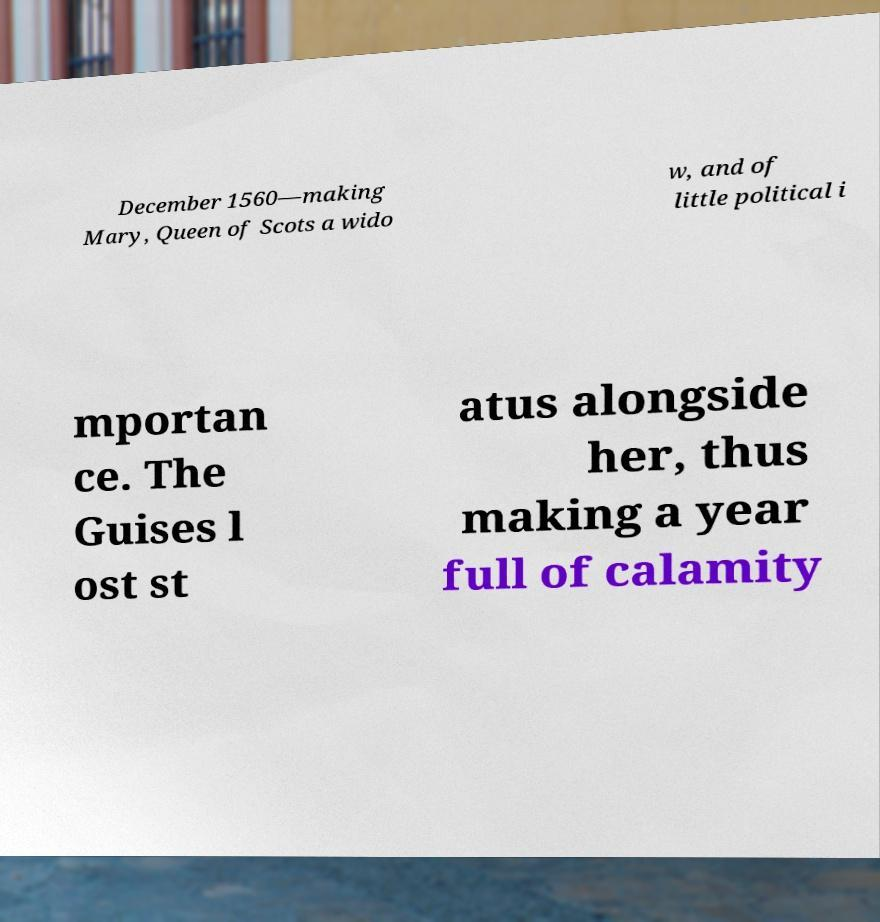There's text embedded in this image that I need extracted. Can you transcribe it verbatim? December 1560—making Mary, Queen of Scots a wido w, and of little political i mportan ce. The Guises l ost st atus alongside her, thus making a year full of calamity 